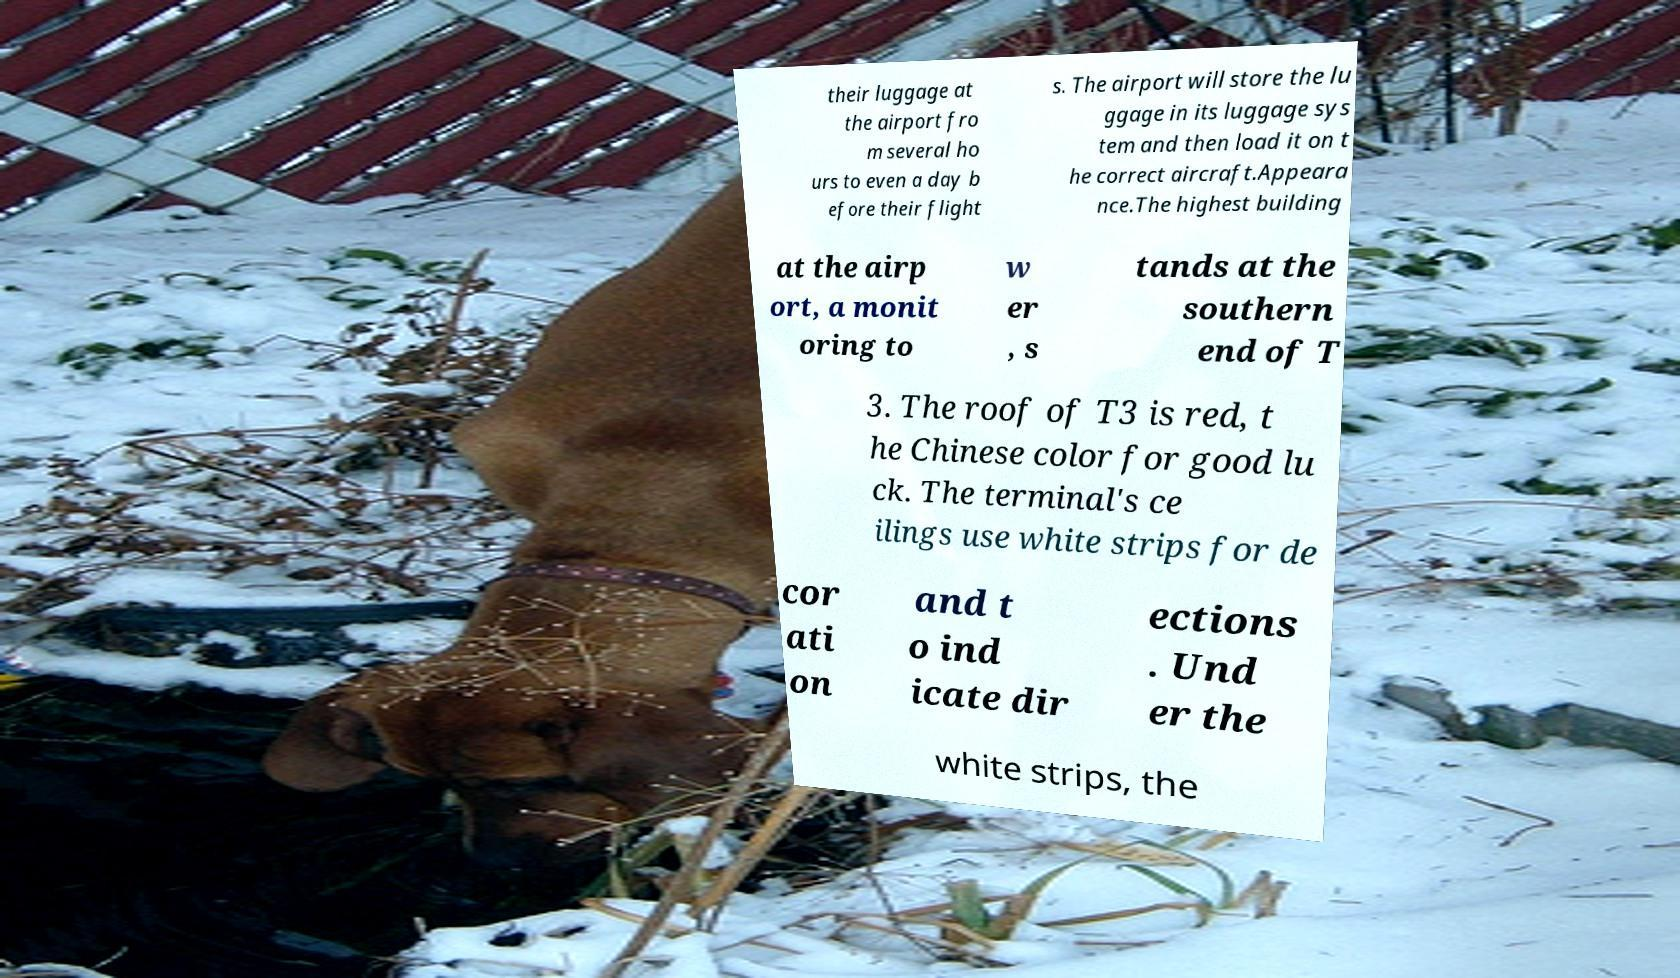Please read and relay the text visible in this image. What does it say? their luggage at the airport fro m several ho urs to even a day b efore their flight s. The airport will store the lu ggage in its luggage sys tem and then load it on t he correct aircraft.Appeara nce.The highest building at the airp ort, a monit oring to w er , s tands at the southern end of T 3. The roof of T3 is red, t he Chinese color for good lu ck. The terminal's ce ilings use white strips for de cor ati on and t o ind icate dir ections . Und er the white strips, the 